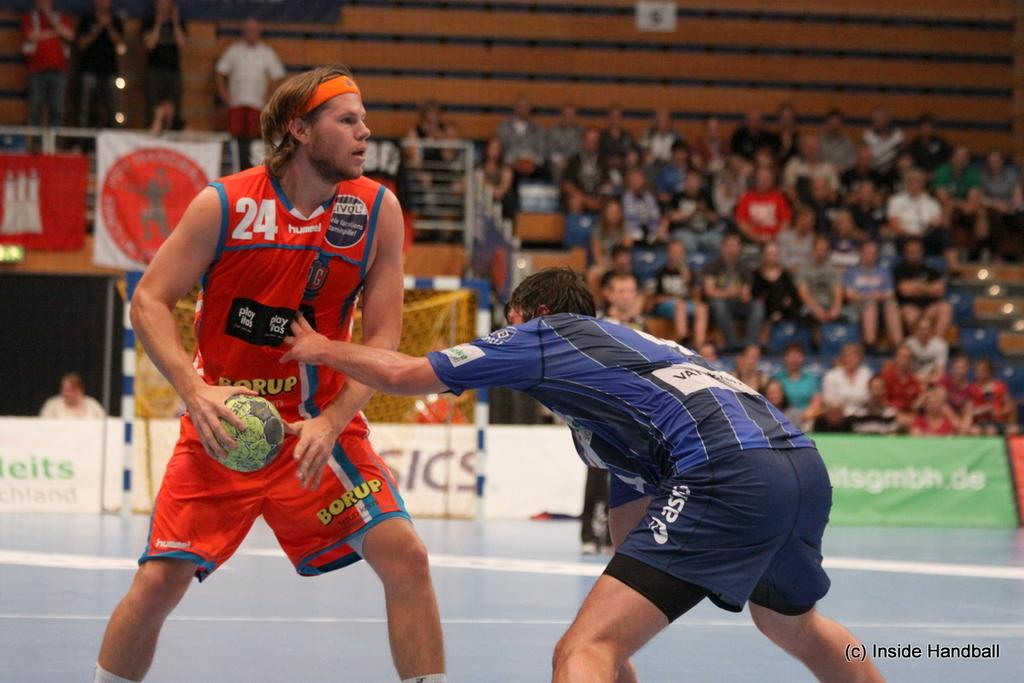<image>
Write a terse but informative summary of the picture. men playing handball one in a 24 jersey the other in blue and white stripes 